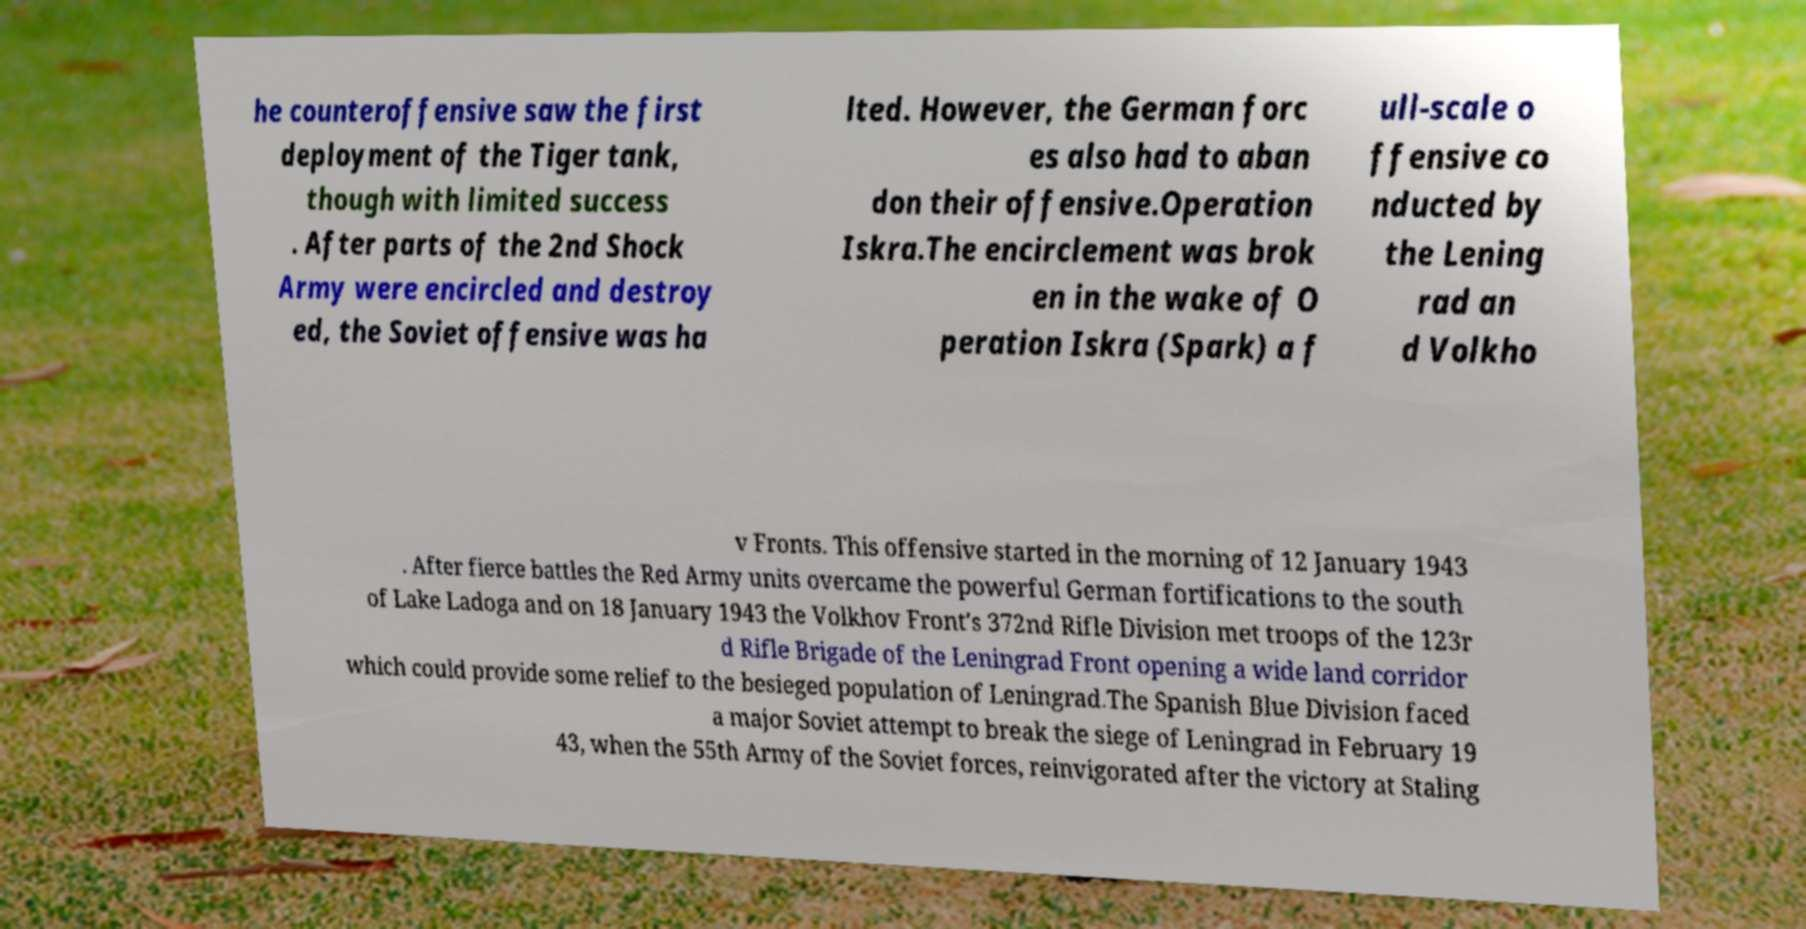Please identify and transcribe the text found in this image. he counteroffensive saw the first deployment of the Tiger tank, though with limited success . After parts of the 2nd Shock Army were encircled and destroy ed, the Soviet offensive was ha lted. However, the German forc es also had to aban don their offensive.Operation Iskra.The encirclement was brok en in the wake of O peration Iskra (Spark) a f ull-scale o ffensive co nducted by the Lening rad an d Volkho v Fronts. This offensive started in the morning of 12 January 1943 . After fierce battles the Red Army units overcame the powerful German fortifications to the south of Lake Ladoga and on 18 January 1943 the Volkhov Front's 372nd Rifle Division met troops of the 123r d Rifle Brigade of the Leningrad Front opening a wide land corridor which could provide some relief to the besieged population of Leningrad.The Spanish Blue Division faced a major Soviet attempt to break the siege of Leningrad in February 19 43, when the 55th Army of the Soviet forces, reinvigorated after the victory at Staling 